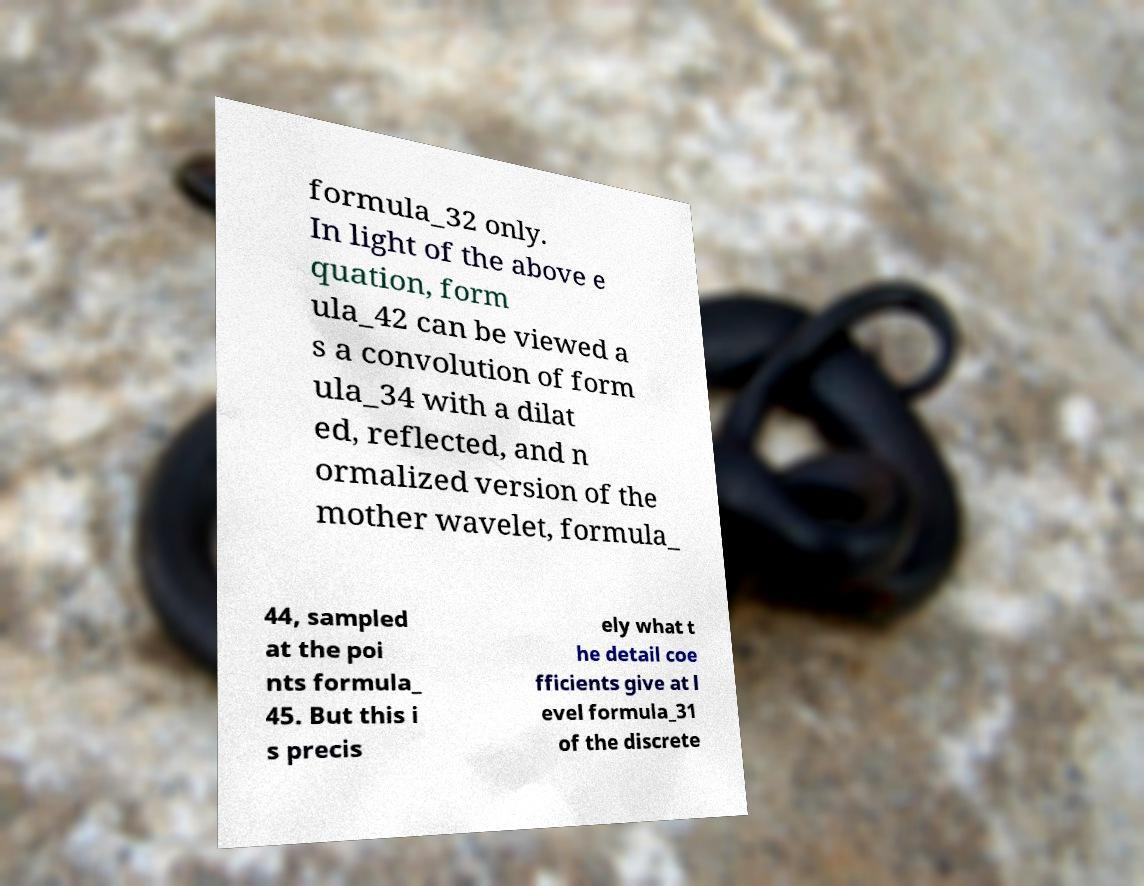Can you accurately transcribe the text from the provided image for me? formula_32 only. In light of the above e quation, form ula_42 can be viewed a s a convolution of form ula_34 with a dilat ed, reflected, and n ormalized version of the mother wavelet, formula_ 44, sampled at the poi nts formula_ 45. But this i s precis ely what t he detail coe fficients give at l evel formula_31 of the discrete 